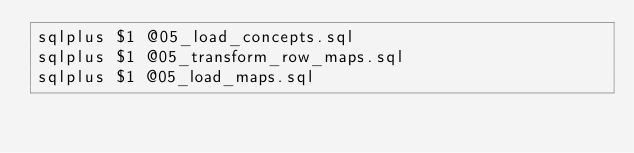<code> <loc_0><loc_0><loc_500><loc_500><_Bash_>sqlplus $1 @05_load_concepts.sql
sqlplus $1 @05_transform_row_maps.sql
sqlplus $1 @05_load_maps.sql</code> 